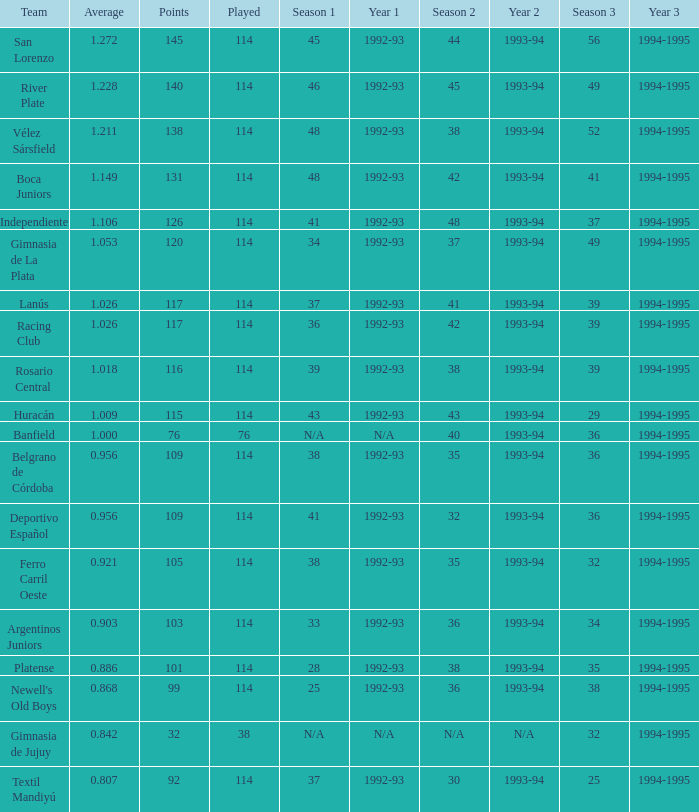Name the most played 114.0. 